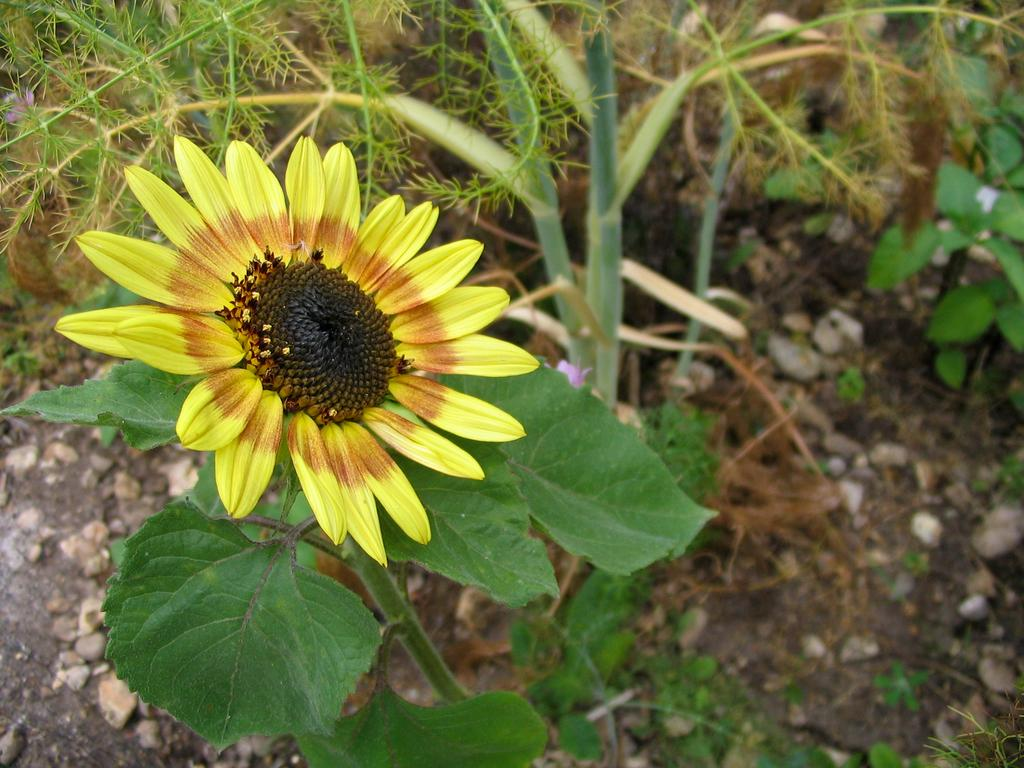What is the main subject of the image? There is a flower in the image. What can be seen in the background of the image? There are plants and stones on the ground in the background of the image. What type of boundary can be seen in the image? There is no boundary present in the image. Can you spot a giraffe in the image? There is no giraffe present in the image. 